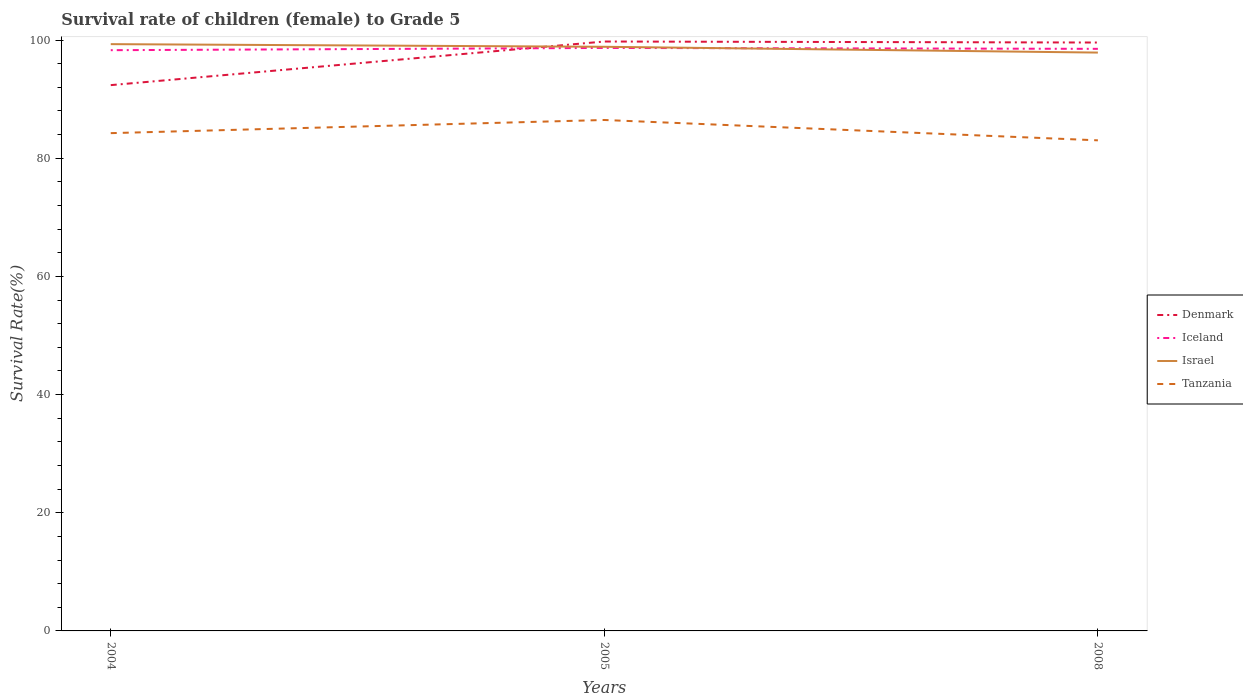How many different coloured lines are there?
Give a very brief answer. 4. Across all years, what is the maximum survival rate of female children to grade 5 in Iceland?
Your answer should be compact. 98.29. In which year was the survival rate of female children to grade 5 in Denmark maximum?
Offer a very short reply. 2004. What is the total survival rate of female children to grade 5 in Israel in the graph?
Provide a succinct answer. 0.98. What is the difference between the highest and the second highest survival rate of female children to grade 5 in Israel?
Your answer should be very brief. 1.43. Is the survival rate of female children to grade 5 in Tanzania strictly greater than the survival rate of female children to grade 5 in Israel over the years?
Give a very brief answer. Yes. Does the graph contain grids?
Give a very brief answer. No. How are the legend labels stacked?
Your answer should be compact. Vertical. What is the title of the graph?
Offer a very short reply. Survival rate of children (female) to Grade 5. What is the label or title of the X-axis?
Provide a short and direct response. Years. What is the label or title of the Y-axis?
Ensure brevity in your answer.  Survival Rate(%). What is the Survival Rate(%) in Denmark in 2004?
Provide a succinct answer. 92.38. What is the Survival Rate(%) in Iceland in 2004?
Offer a terse response. 98.29. What is the Survival Rate(%) in Israel in 2004?
Provide a short and direct response. 99.31. What is the Survival Rate(%) of Tanzania in 2004?
Your answer should be very brief. 84.25. What is the Survival Rate(%) of Denmark in 2005?
Your response must be concise. 99.76. What is the Survival Rate(%) in Iceland in 2005?
Offer a terse response. 98.67. What is the Survival Rate(%) in Israel in 2005?
Your answer should be compact. 98.87. What is the Survival Rate(%) of Tanzania in 2005?
Keep it short and to the point. 86.48. What is the Survival Rate(%) in Denmark in 2008?
Make the answer very short. 99.59. What is the Survival Rate(%) in Iceland in 2008?
Make the answer very short. 98.52. What is the Survival Rate(%) of Israel in 2008?
Offer a very short reply. 97.89. What is the Survival Rate(%) of Tanzania in 2008?
Provide a short and direct response. 83.03. Across all years, what is the maximum Survival Rate(%) of Denmark?
Give a very brief answer. 99.76. Across all years, what is the maximum Survival Rate(%) in Iceland?
Keep it short and to the point. 98.67. Across all years, what is the maximum Survival Rate(%) in Israel?
Provide a succinct answer. 99.31. Across all years, what is the maximum Survival Rate(%) of Tanzania?
Ensure brevity in your answer.  86.48. Across all years, what is the minimum Survival Rate(%) of Denmark?
Provide a succinct answer. 92.38. Across all years, what is the minimum Survival Rate(%) in Iceland?
Offer a terse response. 98.29. Across all years, what is the minimum Survival Rate(%) of Israel?
Your response must be concise. 97.89. Across all years, what is the minimum Survival Rate(%) of Tanzania?
Your answer should be compact. 83.03. What is the total Survival Rate(%) of Denmark in the graph?
Your answer should be very brief. 291.72. What is the total Survival Rate(%) in Iceland in the graph?
Your response must be concise. 295.48. What is the total Survival Rate(%) in Israel in the graph?
Your answer should be compact. 296.07. What is the total Survival Rate(%) in Tanzania in the graph?
Provide a succinct answer. 253.76. What is the difference between the Survival Rate(%) in Denmark in 2004 and that in 2005?
Ensure brevity in your answer.  -7.38. What is the difference between the Survival Rate(%) in Iceland in 2004 and that in 2005?
Your answer should be compact. -0.38. What is the difference between the Survival Rate(%) of Israel in 2004 and that in 2005?
Offer a very short reply. 0.45. What is the difference between the Survival Rate(%) in Tanzania in 2004 and that in 2005?
Provide a short and direct response. -2.23. What is the difference between the Survival Rate(%) of Denmark in 2004 and that in 2008?
Your response must be concise. -7.21. What is the difference between the Survival Rate(%) of Iceland in 2004 and that in 2008?
Ensure brevity in your answer.  -0.23. What is the difference between the Survival Rate(%) of Israel in 2004 and that in 2008?
Your answer should be very brief. 1.43. What is the difference between the Survival Rate(%) of Tanzania in 2004 and that in 2008?
Provide a succinct answer. 1.22. What is the difference between the Survival Rate(%) in Denmark in 2005 and that in 2008?
Offer a very short reply. 0.17. What is the difference between the Survival Rate(%) in Iceland in 2005 and that in 2008?
Provide a succinct answer. 0.15. What is the difference between the Survival Rate(%) in Israel in 2005 and that in 2008?
Offer a very short reply. 0.98. What is the difference between the Survival Rate(%) in Tanzania in 2005 and that in 2008?
Your response must be concise. 3.44. What is the difference between the Survival Rate(%) in Denmark in 2004 and the Survival Rate(%) in Iceland in 2005?
Make the answer very short. -6.29. What is the difference between the Survival Rate(%) in Denmark in 2004 and the Survival Rate(%) in Israel in 2005?
Your answer should be compact. -6.49. What is the difference between the Survival Rate(%) of Denmark in 2004 and the Survival Rate(%) of Tanzania in 2005?
Provide a short and direct response. 5.9. What is the difference between the Survival Rate(%) of Iceland in 2004 and the Survival Rate(%) of Israel in 2005?
Offer a terse response. -0.58. What is the difference between the Survival Rate(%) in Iceland in 2004 and the Survival Rate(%) in Tanzania in 2005?
Your answer should be compact. 11.81. What is the difference between the Survival Rate(%) of Israel in 2004 and the Survival Rate(%) of Tanzania in 2005?
Give a very brief answer. 12.84. What is the difference between the Survival Rate(%) in Denmark in 2004 and the Survival Rate(%) in Iceland in 2008?
Ensure brevity in your answer.  -6.14. What is the difference between the Survival Rate(%) in Denmark in 2004 and the Survival Rate(%) in Israel in 2008?
Your answer should be very brief. -5.51. What is the difference between the Survival Rate(%) in Denmark in 2004 and the Survival Rate(%) in Tanzania in 2008?
Your answer should be very brief. 9.34. What is the difference between the Survival Rate(%) in Iceland in 2004 and the Survival Rate(%) in Israel in 2008?
Provide a short and direct response. 0.4. What is the difference between the Survival Rate(%) in Iceland in 2004 and the Survival Rate(%) in Tanzania in 2008?
Keep it short and to the point. 15.26. What is the difference between the Survival Rate(%) of Israel in 2004 and the Survival Rate(%) of Tanzania in 2008?
Make the answer very short. 16.28. What is the difference between the Survival Rate(%) of Denmark in 2005 and the Survival Rate(%) of Iceland in 2008?
Provide a short and direct response. 1.24. What is the difference between the Survival Rate(%) of Denmark in 2005 and the Survival Rate(%) of Israel in 2008?
Provide a succinct answer. 1.87. What is the difference between the Survival Rate(%) of Denmark in 2005 and the Survival Rate(%) of Tanzania in 2008?
Make the answer very short. 16.72. What is the difference between the Survival Rate(%) in Iceland in 2005 and the Survival Rate(%) in Israel in 2008?
Make the answer very short. 0.78. What is the difference between the Survival Rate(%) of Iceland in 2005 and the Survival Rate(%) of Tanzania in 2008?
Keep it short and to the point. 15.64. What is the difference between the Survival Rate(%) of Israel in 2005 and the Survival Rate(%) of Tanzania in 2008?
Your response must be concise. 15.83. What is the average Survival Rate(%) in Denmark per year?
Offer a terse response. 97.24. What is the average Survival Rate(%) in Iceland per year?
Your answer should be compact. 98.49. What is the average Survival Rate(%) of Israel per year?
Your answer should be very brief. 98.69. What is the average Survival Rate(%) in Tanzania per year?
Give a very brief answer. 84.59. In the year 2004, what is the difference between the Survival Rate(%) of Denmark and Survival Rate(%) of Iceland?
Offer a terse response. -5.91. In the year 2004, what is the difference between the Survival Rate(%) of Denmark and Survival Rate(%) of Israel?
Keep it short and to the point. -6.94. In the year 2004, what is the difference between the Survival Rate(%) in Denmark and Survival Rate(%) in Tanzania?
Keep it short and to the point. 8.13. In the year 2004, what is the difference between the Survival Rate(%) of Iceland and Survival Rate(%) of Israel?
Offer a very short reply. -1.02. In the year 2004, what is the difference between the Survival Rate(%) in Iceland and Survival Rate(%) in Tanzania?
Give a very brief answer. 14.04. In the year 2004, what is the difference between the Survival Rate(%) of Israel and Survival Rate(%) of Tanzania?
Your answer should be very brief. 15.06. In the year 2005, what is the difference between the Survival Rate(%) in Denmark and Survival Rate(%) in Iceland?
Your answer should be very brief. 1.09. In the year 2005, what is the difference between the Survival Rate(%) in Denmark and Survival Rate(%) in Israel?
Offer a very short reply. 0.89. In the year 2005, what is the difference between the Survival Rate(%) of Denmark and Survival Rate(%) of Tanzania?
Your answer should be compact. 13.28. In the year 2005, what is the difference between the Survival Rate(%) of Iceland and Survival Rate(%) of Israel?
Provide a short and direct response. -0.2. In the year 2005, what is the difference between the Survival Rate(%) of Iceland and Survival Rate(%) of Tanzania?
Your answer should be compact. 12.19. In the year 2005, what is the difference between the Survival Rate(%) of Israel and Survival Rate(%) of Tanzania?
Make the answer very short. 12.39. In the year 2008, what is the difference between the Survival Rate(%) of Denmark and Survival Rate(%) of Iceland?
Keep it short and to the point. 1.07. In the year 2008, what is the difference between the Survival Rate(%) in Denmark and Survival Rate(%) in Israel?
Make the answer very short. 1.7. In the year 2008, what is the difference between the Survival Rate(%) of Denmark and Survival Rate(%) of Tanzania?
Offer a very short reply. 16.55. In the year 2008, what is the difference between the Survival Rate(%) in Iceland and Survival Rate(%) in Israel?
Your answer should be very brief. 0.63. In the year 2008, what is the difference between the Survival Rate(%) in Iceland and Survival Rate(%) in Tanzania?
Provide a short and direct response. 15.49. In the year 2008, what is the difference between the Survival Rate(%) in Israel and Survival Rate(%) in Tanzania?
Provide a succinct answer. 14.85. What is the ratio of the Survival Rate(%) of Denmark in 2004 to that in 2005?
Ensure brevity in your answer.  0.93. What is the ratio of the Survival Rate(%) in Iceland in 2004 to that in 2005?
Your response must be concise. 1. What is the ratio of the Survival Rate(%) in Tanzania in 2004 to that in 2005?
Offer a terse response. 0.97. What is the ratio of the Survival Rate(%) in Denmark in 2004 to that in 2008?
Your response must be concise. 0.93. What is the ratio of the Survival Rate(%) of Israel in 2004 to that in 2008?
Ensure brevity in your answer.  1.01. What is the ratio of the Survival Rate(%) in Tanzania in 2004 to that in 2008?
Offer a very short reply. 1.01. What is the ratio of the Survival Rate(%) of Denmark in 2005 to that in 2008?
Keep it short and to the point. 1. What is the ratio of the Survival Rate(%) of Tanzania in 2005 to that in 2008?
Keep it short and to the point. 1.04. What is the difference between the highest and the second highest Survival Rate(%) of Denmark?
Ensure brevity in your answer.  0.17. What is the difference between the highest and the second highest Survival Rate(%) in Iceland?
Ensure brevity in your answer.  0.15. What is the difference between the highest and the second highest Survival Rate(%) of Israel?
Your answer should be compact. 0.45. What is the difference between the highest and the second highest Survival Rate(%) of Tanzania?
Your answer should be very brief. 2.23. What is the difference between the highest and the lowest Survival Rate(%) of Denmark?
Make the answer very short. 7.38. What is the difference between the highest and the lowest Survival Rate(%) in Iceland?
Offer a very short reply. 0.38. What is the difference between the highest and the lowest Survival Rate(%) in Israel?
Your answer should be compact. 1.43. What is the difference between the highest and the lowest Survival Rate(%) in Tanzania?
Your response must be concise. 3.44. 